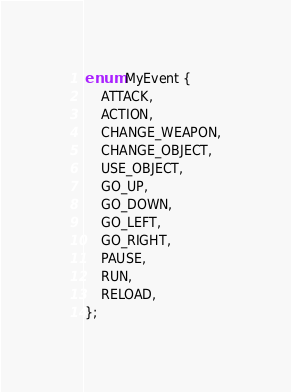Convert code to text. <code><loc_0><loc_0><loc_500><loc_500><_C_>enum MyEvent { 
	ATTACK,
	ACTION,
	CHANGE_WEAPON,
	CHANGE_OBJECT,
	USE_OBJECT,
	GO_UP, 
	GO_DOWN, 
	GO_LEFT, 
	GO_RIGHT,
	PAUSE,
	RUN,
	RELOAD,
};</code> 